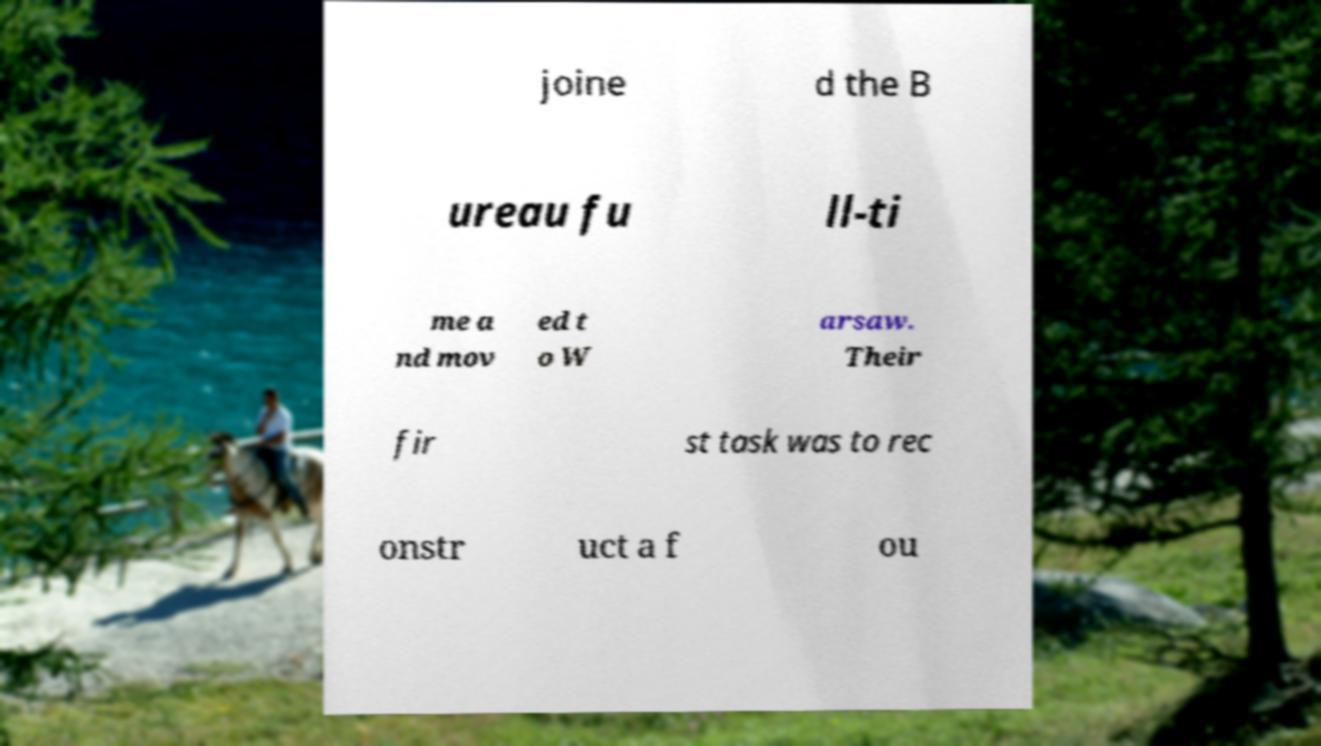There's text embedded in this image that I need extracted. Can you transcribe it verbatim? joine d the B ureau fu ll-ti me a nd mov ed t o W arsaw. Their fir st task was to rec onstr uct a f ou 